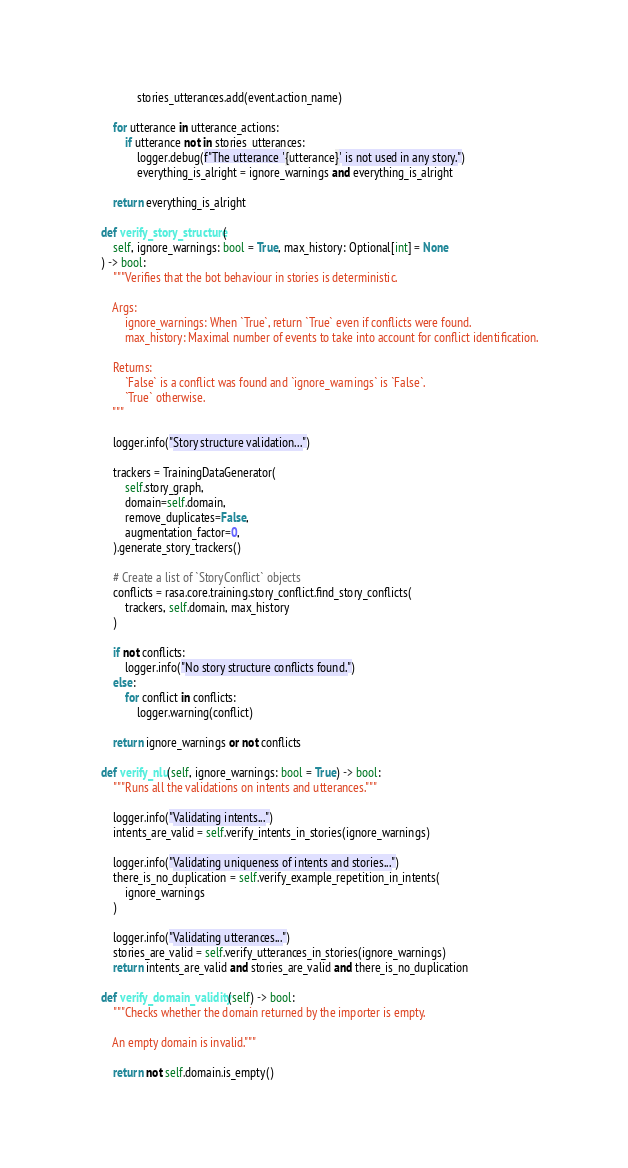Convert code to text. <code><loc_0><loc_0><loc_500><loc_500><_Python_>                stories_utterances.add(event.action_name)

        for utterance in utterance_actions:
            if utterance not in stories_utterances:
                logger.debug(f"The utterance '{utterance}' is not used in any story.")
                everything_is_alright = ignore_warnings and everything_is_alright

        return everything_is_alright

    def verify_story_structure(
        self, ignore_warnings: bool = True, max_history: Optional[int] = None
    ) -> bool:
        """Verifies that the bot behaviour in stories is deterministic.

        Args:
            ignore_warnings: When `True`, return `True` even if conflicts were found.
            max_history: Maximal number of events to take into account for conflict identification.

        Returns:
            `False` is a conflict was found and `ignore_warnings` is `False`.
            `True` otherwise.
        """

        logger.info("Story structure validation...")

        trackers = TrainingDataGenerator(
            self.story_graph,
            domain=self.domain,
            remove_duplicates=False,
            augmentation_factor=0,
        ).generate_story_trackers()

        # Create a list of `StoryConflict` objects
        conflicts = rasa.core.training.story_conflict.find_story_conflicts(
            trackers, self.domain, max_history
        )

        if not conflicts:
            logger.info("No story structure conflicts found.")
        else:
            for conflict in conflicts:
                logger.warning(conflict)

        return ignore_warnings or not conflicts

    def verify_nlu(self, ignore_warnings: bool = True) -> bool:
        """Runs all the validations on intents and utterances."""

        logger.info("Validating intents...")
        intents_are_valid = self.verify_intents_in_stories(ignore_warnings)

        logger.info("Validating uniqueness of intents and stories...")
        there_is_no_duplication = self.verify_example_repetition_in_intents(
            ignore_warnings
        )

        logger.info("Validating utterances...")
        stories_are_valid = self.verify_utterances_in_stories(ignore_warnings)
        return intents_are_valid and stories_are_valid and there_is_no_duplication

    def verify_domain_validity(self) -> bool:
        """Checks whether the domain returned by the importer is empty.

        An empty domain is invalid."""

        return not self.domain.is_empty()
</code> 